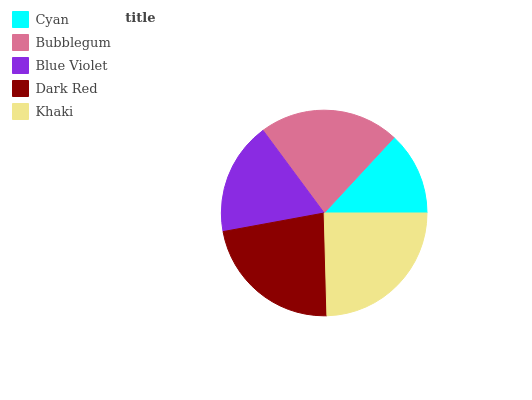Is Cyan the minimum?
Answer yes or no. Yes. Is Khaki the maximum?
Answer yes or no. Yes. Is Bubblegum the minimum?
Answer yes or no. No. Is Bubblegum the maximum?
Answer yes or no. No. Is Bubblegum greater than Cyan?
Answer yes or no. Yes. Is Cyan less than Bubblegum?
Answer yes or no. Yes. Is Cyan greater than Bubblegum?
Answer yes or no. No. Is Bubblegum less than Cyan?
Answer yes or no. No. Is Bubblegum the high median?
Answer yes or no. Yes. Is Bubblegum the low median?
Answer yes or no. Yes. Is Blue Violet the high median?
Answer yes or no. No. Is Khaki the low median?
Answer yes or no. No. 